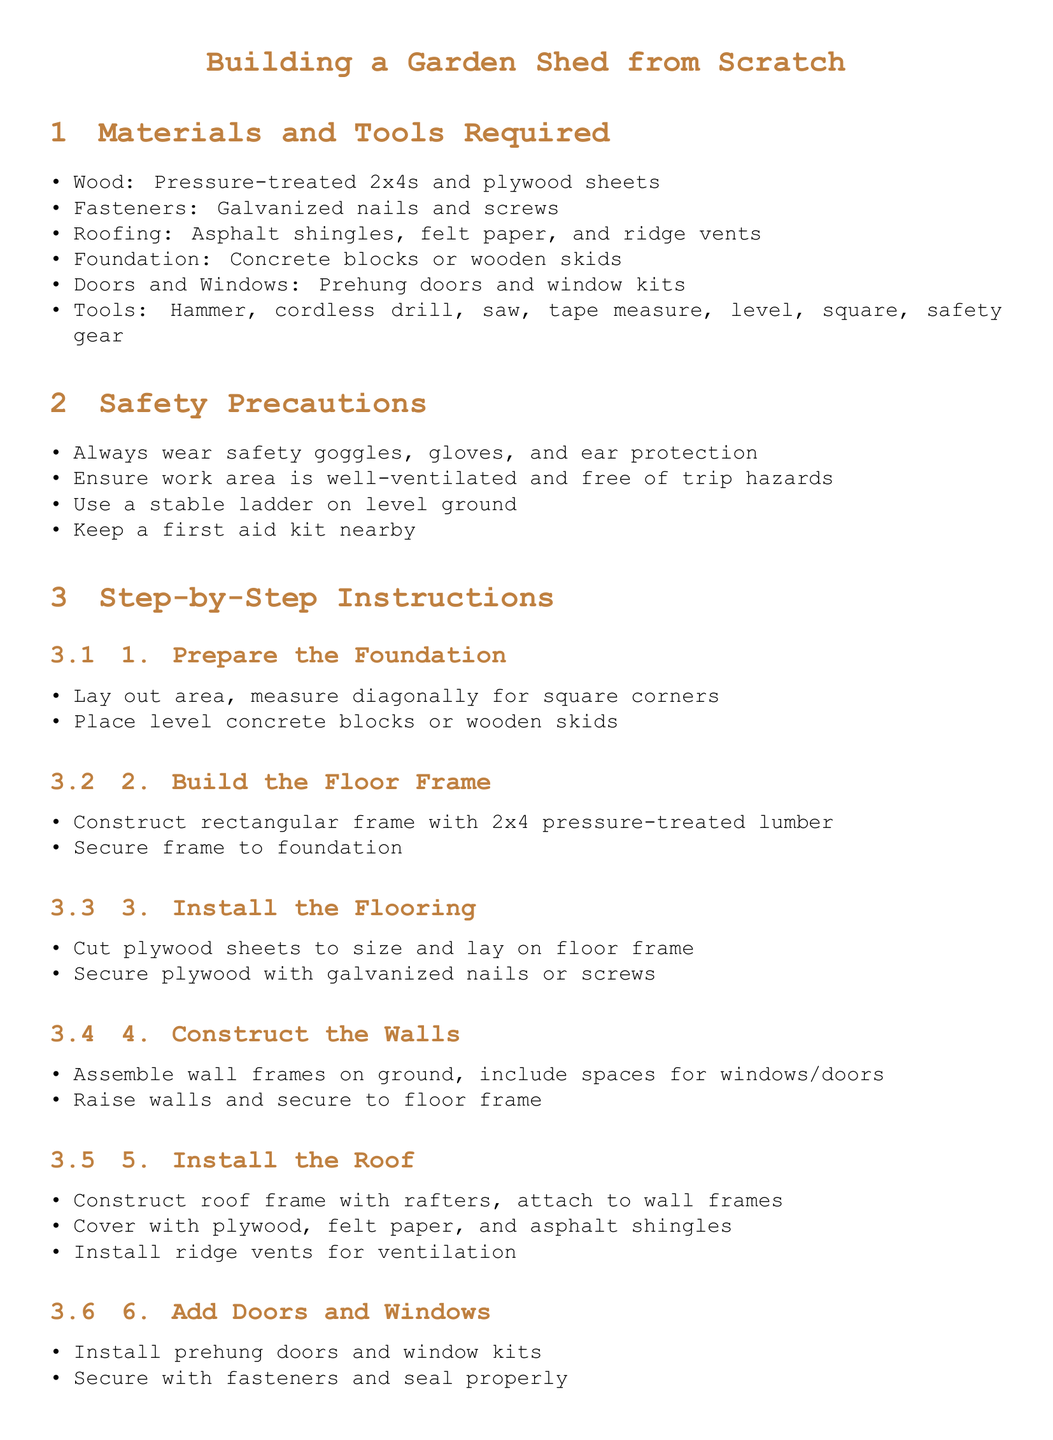What type of wood is recommended for the project? The document specifies the use of pressure-treated 2x4s and plywood sheets for the construction of the garden shed.
Answer: Pressure-treated 2x4s and plywood sheets What safety gear should be worn? The instructions highlight the importance of wearing safety goggles, gloves, and ear protection when building the shed.
Answer: Safety goggles, gloves, and ear protection How many steps are outlined in the instructions? The document presents a total of seven steps for building the garden shed outlined in the step-by-step instructions section.
Answer: 7 What is the first step in building the garden shed? The initial step in the assembly instructions is to prepare the foundation for the shed.
Answer: Prepare the Foundation What tool is mentioned for securing plywood? The instructions indicate the use of galvanized nails or screws to secure the plywood to the floor frame.
Answer: Galvanized nails or screws Which component is used for ventilation in the roof? The instructions specify installing ridge vents as part of the roofing process for ventilation purposes.
Answer: Ridge vents What is one of the final touches suggested? The document suggests painting or staining the shed as one of the final touches to complete the project.
Answer: Paint or stain What type of doors is recommended for installation? The instructions recommend using prehung doors for ease of installation in the shed.
Answer: Prehung doors 